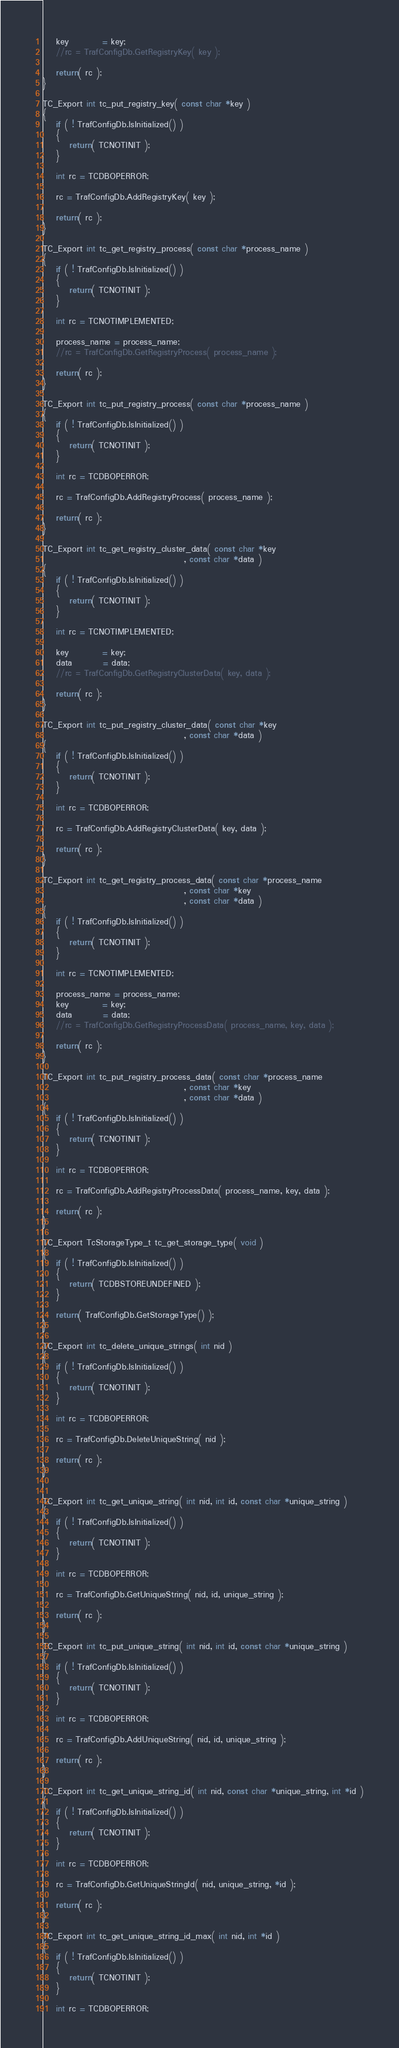<code> <loc_0><loc_0><loc_500><loc_500><_C++_>    key          = key;
    //rc = TrafConfigDb.GetRegistryKey( key );

    return( rc );
}

TC_Export int tc_put_registry_key( const char *key )
{
    if ( ! TrafConfigDb.IsInitialized() )
    {
        return( TCNOTINIT );
    }

    int rc = TCDBOPERROR;

    rc = TrafConfigDb.AddRegistryKey( key );

    return( rc );
}

TC_Export int tc_get_registry_process( const char *process_name )
{
    if ( ! TrafConfigDb.IsInitialized() )
    {
        return( TCNOTINIT );
    }

    int rc = TCNOTIMPLEMENTED;

    process_name = process_name;
    //rc = TrafConfigDb.GetRegistryProcess( process_name );

    return( rc );
}

TC_Export int tc_put_registry_process( const char *process_name )
{
    if ( ! TrafConfigDb.IsInitialized() )
    {
        return( TCNOTINIT );
    }

    int rc = TCDBOPERROR;

    rc = TrafConfigDb.AddRegistryProcess( process_name );

    return( rc );
}

TC_Export int tc_get_registry_cluster_data( const char *key
                                          , const char *data )
{
    if ( ! TrafConfigDb.IsInitialized() )
    {
        return( TCNOTINIT );
    }

    int rc = TCNOTIMPLEMENTED;

    key          = key;
    data         = data;
    //rc = TrafConfigDb.GetRegistryClusterData( key, data );

    return( rc );
}

TC_Export int tc_put_registry_cluster_data( const char *key
                                          , const char *data )
{
    if ( ! TrafConfigDb.IsInitialized() )
    {
        return( TCNOTINIT );
    }

    int rc = TCDBOPERROR;

    rc = TrafConfigDb.AddRegistryClusterData( key, data );

    return( rc );
}

TC_Export int tc_get_registry_process_data( const char *process_name
                                          , const char *key
                                          , const char *data )
{
    if ( ! TrafConfigDb.IsInitialized() )
    {
        return( TCNOTINIT );
    }

    int rc = TCNOTIMPLEMENTED;

    process_name = process_name;
    key          = key;
    data         = data;
    //rc = TrafConfigDb.GetRegistryProcessData( process_name, key, data );

    return( rc );
}

TC_Export int tc_put_registry_process_data( const char *process_name
                                          , const char *key
                                          , const char *data )
{
    if ( ! TrafConfigDb.IsInitialized() )
    {
        return( TCNOTINIT );
    }

    int rc = TCDBOPERROR;

    rc = TrafConfigDb.AddRegistryProcessData( process_name, key, data );

    return( rc );
}

TC_Export TcStorageType_t tc_get_storage_type( void )
{
    if ( ! TrafConfigDb.IsInitialized() )
    {
        return( TCDBSTOREUNDEFINED );
    }

    return( TrafConfigDb.GetStorageType() );
}

TC_Export int tc_delete_unique_strings( int nid )
{
    if ( ! TrafConfigDb.IsInitialized() )
    {
        return( TCNOTINIT );
    }

    int rc = TCDBOPERROR;

    rc = TrafConfigDb.DeleteUniqueString( nid );

    return( rc );
}


TC_Export int tc_get_unique_string( int nid, int id, const char *unique_string )
{
    if ( ! TrafConfigDb.IsInitialized() )
    {
        return( TCNOTINIT );
    }

    int rc = TCDBOPERROR;

    rc = TrafConfigDb.GetUniqueString( nid, id, unique_string );

    return( rc );
}

TC_Export int tc_put_unique_string( int nid, int id, const char *unique_string )
{
    if ( ! TrafConfigDb.IsInitialized() )
    {
        return( TCNOTINIT );
    }

    int rc = TCDBOPERROR;

    rc = TrafConfigDb.AddUniqueString( nid, id, unique_string );

    return( rc );
}

TC_Export int tc_get_unique_string_id( int nid, const char *unique_string, int *id )
{
    if ( ! TrafConfigDb.IsInitialized() )
    {
        return( TCNOTINIT );
    }

    int rc = TCDBOPERROR;

    rc = TrafConfigDb.GetUniqueStringId( nid, unique_string, *id );

    return( rc );
}

TC_Export int tc_get_unique_string_id_max( int nid, int *id )
{
    if ( ! TrafConfigDb.IsInitialized() )
    {
        return( TCNOTINIT );
    }

    int rc = TCDBOPERROR;
</code> 